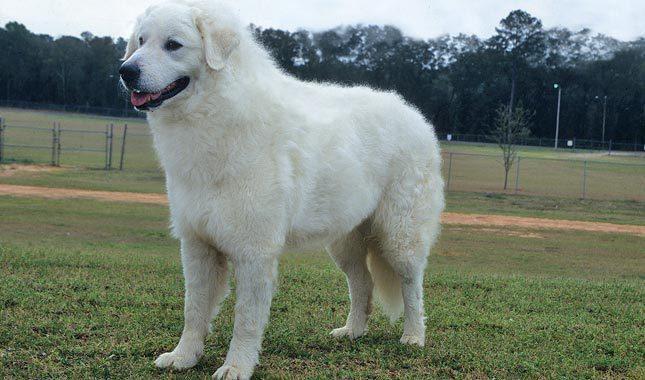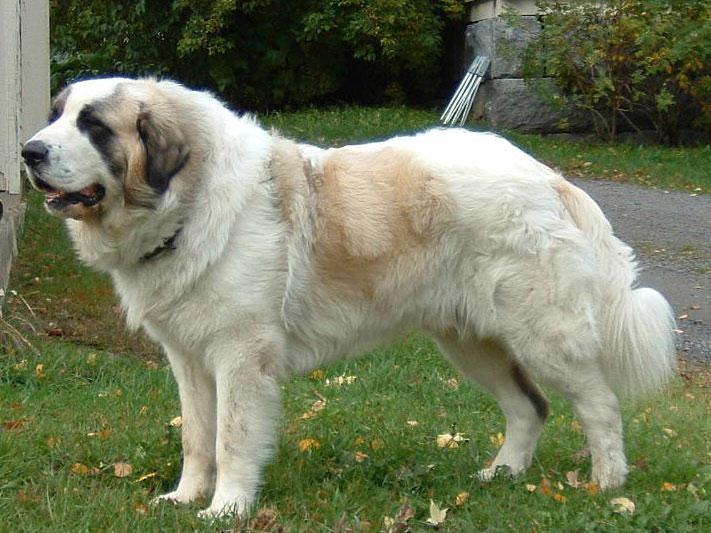The first image is the image on the left, the second image is the image on the right. Assess this claim about the two images: "The image on the left contains only the dog's head and chest.". Correct or not? Answer yes or no. No. 